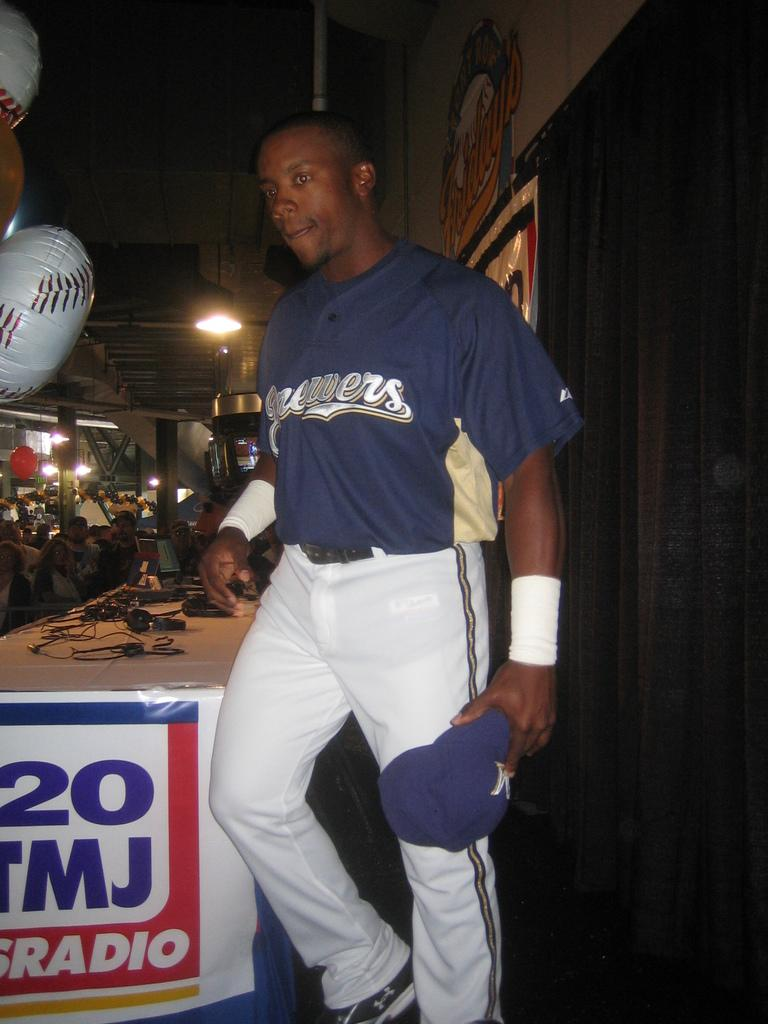<image>
Provide a brief description of the given image. A man wearing baseball gear walks past a sign for sports radio. 